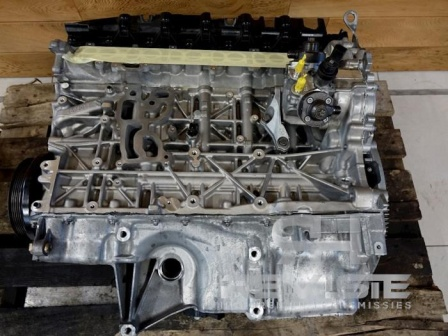Paint an extremely detailed day in the life of this engine block. As the morning rays of sunlight stream into the garage, this engine block awakens from its nocturnal rest on the wooden pallet. The subtle smell of motor oil and the faint odors of rubber and metal fill the air. The garage is quiet for a while, the soft hum of distant machinery providing a gentle backdrop.

A technician enters, their boots clinging to the textured concrete floor. The engine block, still and patient, waits. The technician inspects it, their gloved hands tracing the contours and surfaces, checking for imperfections or wear. Each component is looked over meticulously – the pipes, the covers, the surfaces.

A decision is made: today, the engine will be fitted into a new vehicle. It’s lifted carefully, the pallet creaking slightly under the release of weight. Suspended by machinery, the engine floats gracefully towards the awaiting vehicle chassis. The process is delicate – aligning the engine mounts, connecting the intricate network of pipes and wires, ensuring each element finds its place with precision.

As the day progresses, the garage becomes a symphony of activity. Tools clink and clatter, machines whirr, and voices communicate in a blend of technical jargon. The engine, now nestled within its new home, begins the sequence of connections – fuel lines, cooling system, electrical components – everything methodically integrated.

By late afternoon, it’s time for the first test. The ignition is turned, and the engine roars to life. Its metallic symphony dances through the spaces, echoing off the garage walls. After some initial adjustments and fine-tuning, the engine runs smoothly, a testament to its design and the skill of those who assembled it. The garage fills with a sense of accomplishment as the engine, now revitalized and ready, is prepared for its new adventures on the open road. 